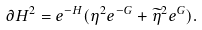Convert formula to latex. <formula><loc_0><loc_0><loc_500><loc_500>\partial H ^ { 2 } = e ^ { - H } ( \eta ^ { 2 } e ^ { - G } + \widetilde { \eta } ^ { 2 } e ^ { G } ) .</formula> 